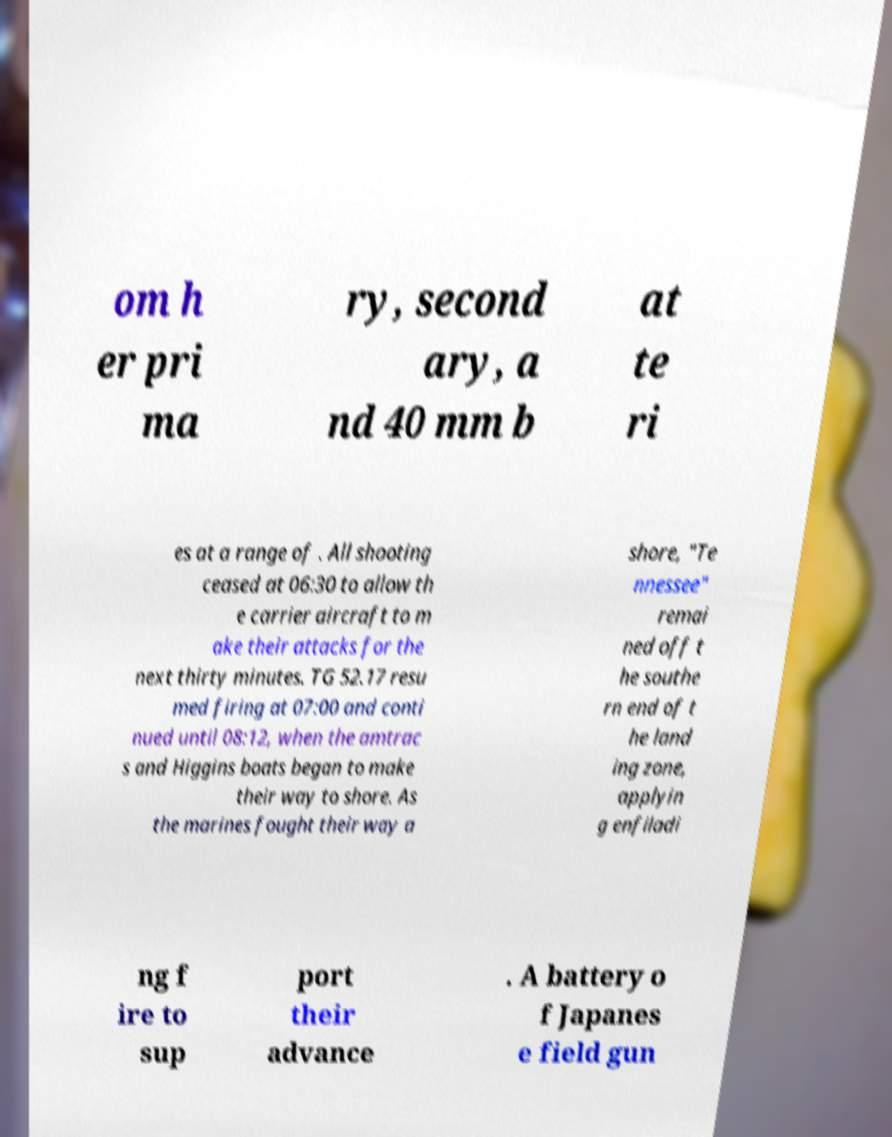Please read and relay the text visible in this image. What does it say? om h er pri ma ry, second ary, a nd 40 mm b at te ri es at a range of . All shooting ceased at 06:30 to allow th e carrier aircraft to m ake their attacks for the next thirty minutes. TG 52.17 resu med firing at 07:00 and conti nued until 08:12, when the amtrac s and Higgins boats began to make their way to shore. As the marines fought their way a shore, "Te nnessee" remai ned off t he southe rn end of t he land ing zone, applyin g enfiladi ng f ire to sup port their advance . A battery o f Japanes e field gun 